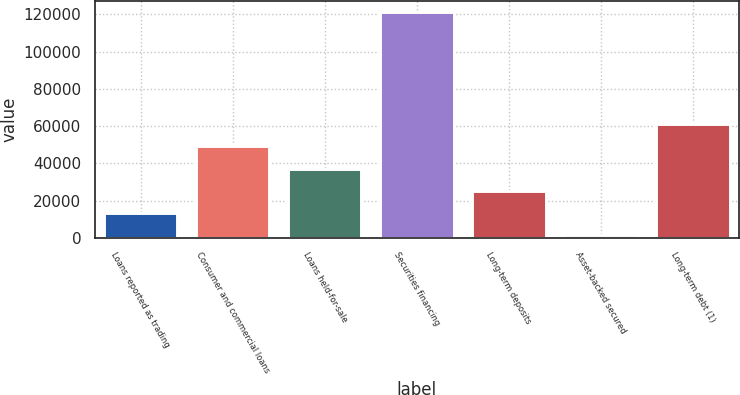Convert chart to OTSL. <chart><loc_0><loc_0><loc_500><loc_500><bar_chart><fcel>Loans reported as trading<fcel>Consumer and commercial loans<fcel>Loans held-for-sale<fcel>Securities financing<fcel>Long-term deposits<fcel>Asset-backed secured<fcel>Long-term debt (1)<nl><fcel>13253.1<fcel>49199.4<fcel>37217.3<fcel>121092<fcel>25235.2<fcel>1271<fcel>61181.5<nl></chart> 